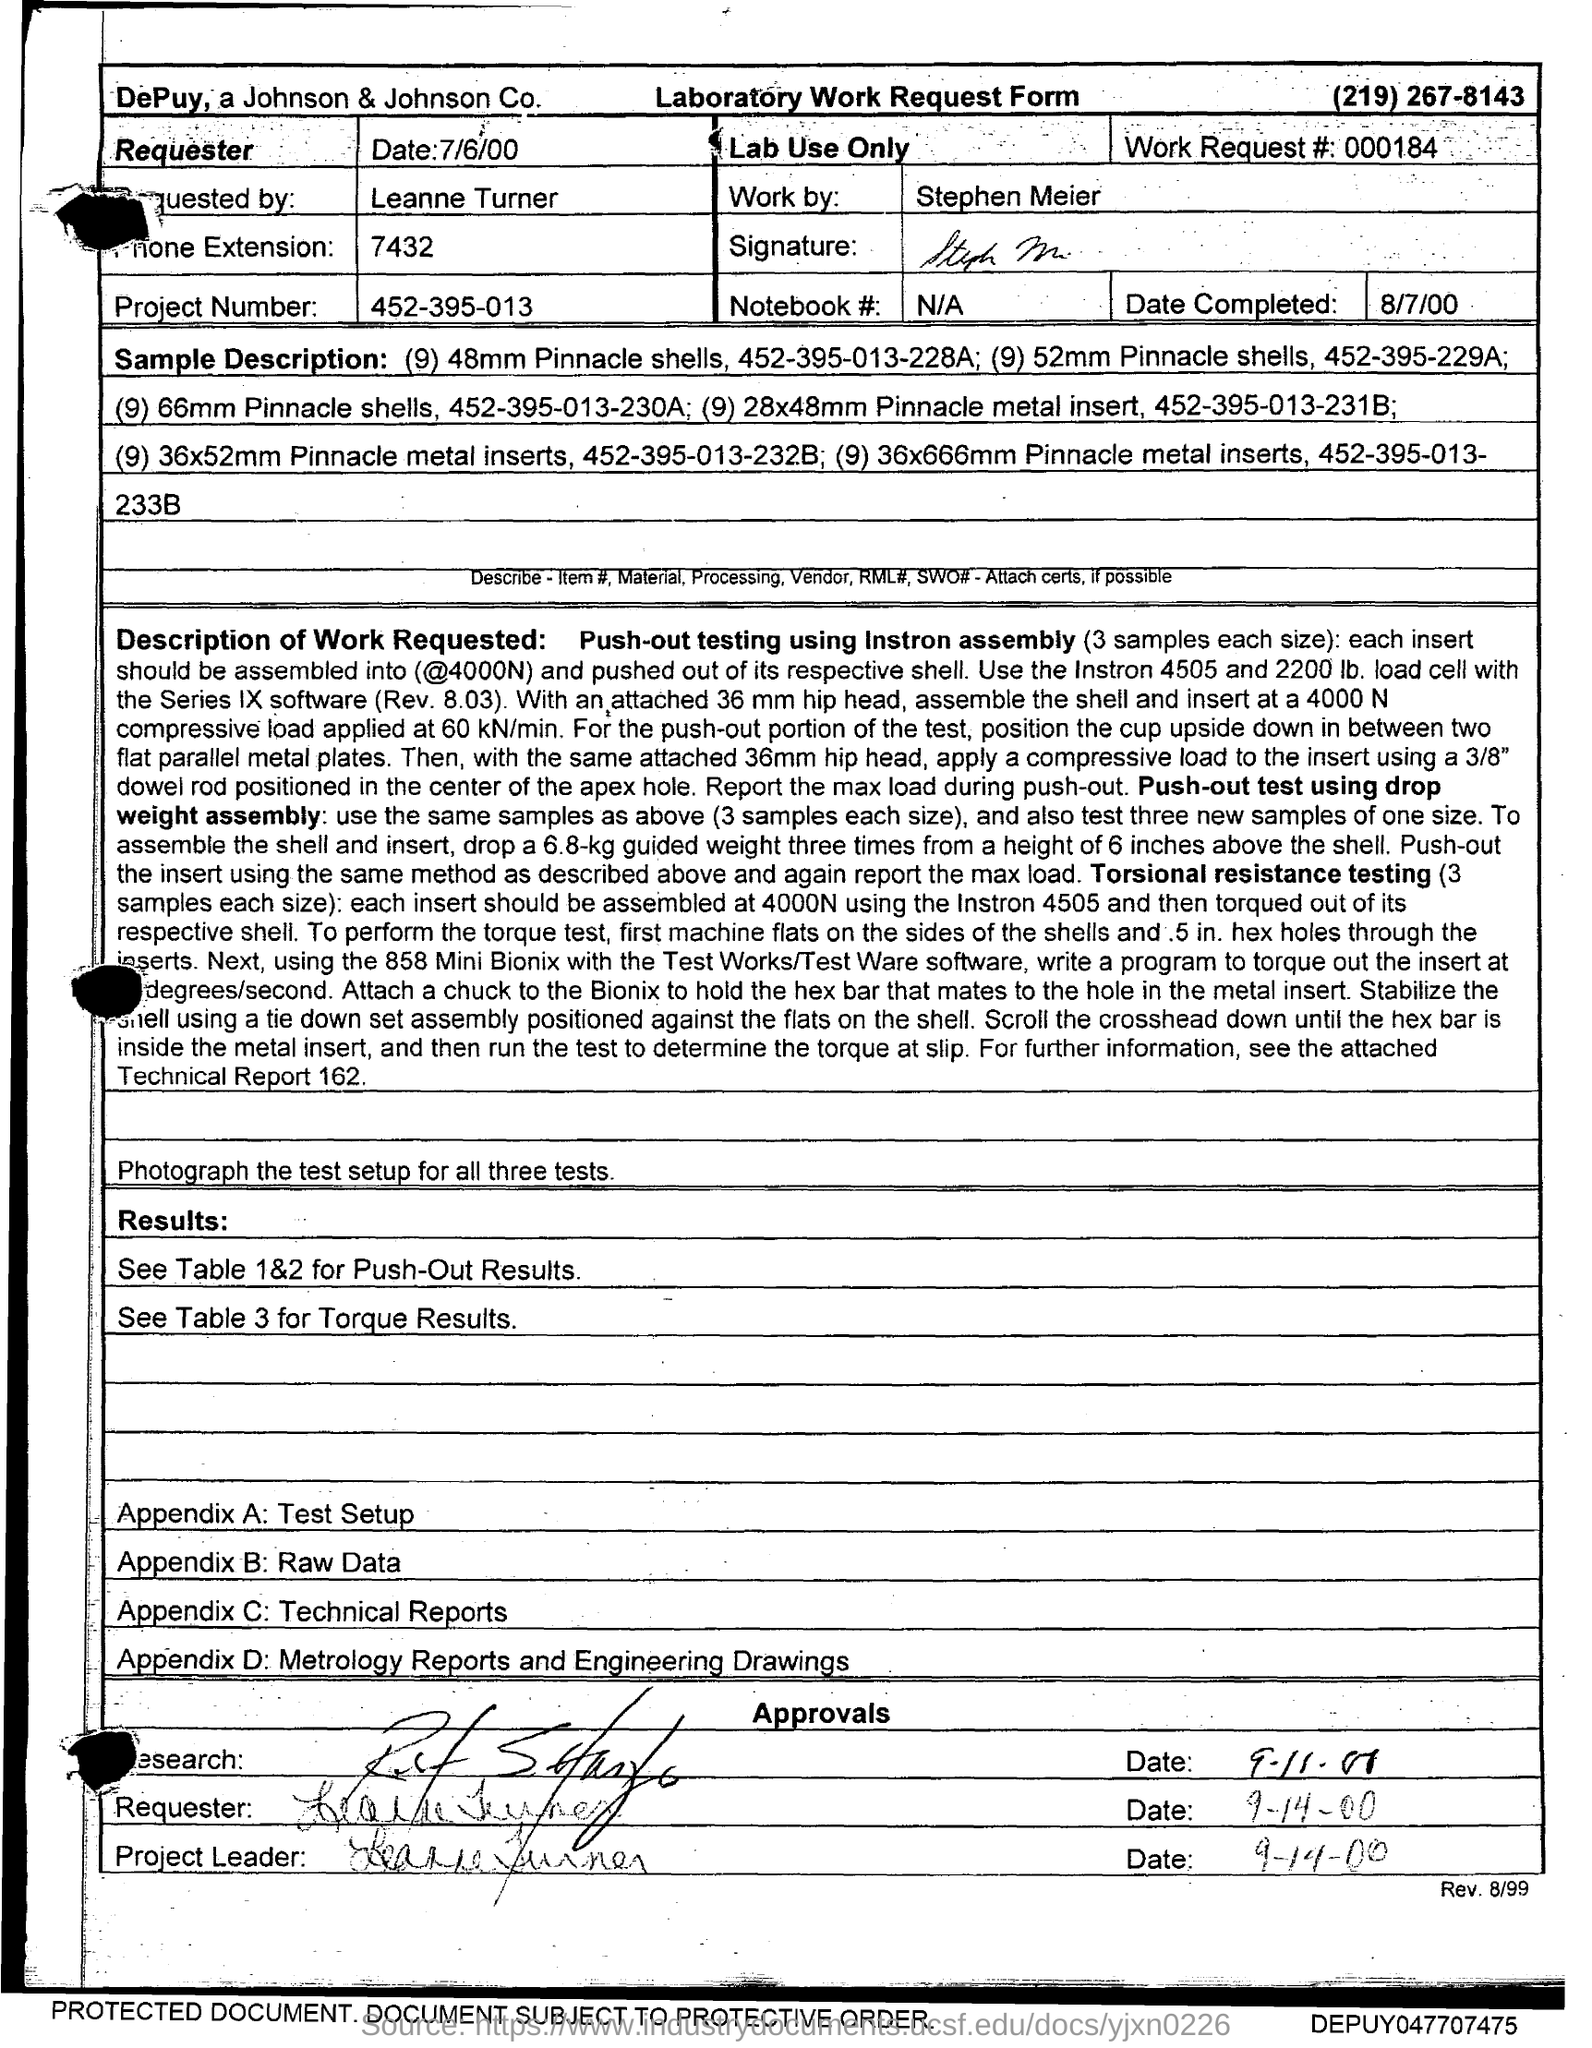What kind of form is given here?
Offer a terse response. Laboratory Work Request Form. Which company's Laboratory Work Request Form is this?
Keep it short and to the point. Depuy, a Johnson & Johnson Co. What is the requester name given in the form?
Your response must be concise. Leanne Turner. What is the work request # given in the form?
Provide a short and direct response. 000184. What is the project number given in the form?
Ensure brevity in your answer.  452-395-013. What is the date of work completion?
Offer a terse response. 8/7/00. What is the Notebook # given in the form?
Make the answer very short. N/A. Who has done the laboratory work?
Give a very brief answer. Stephen Meier. What is the phone extension no given in the form?
Your response must be concise. 7432. 